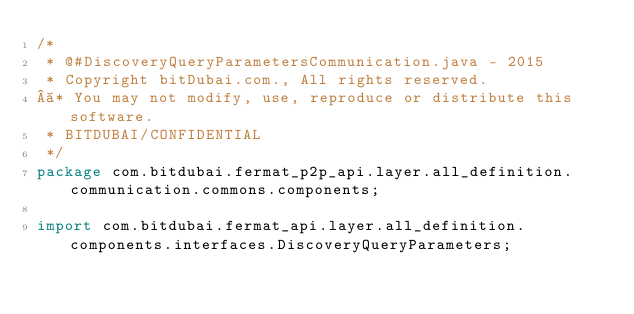<code> <loc_0><loc_0><loc_500><loc_500><_Java_>/*
 * @#DiscoveryQueryParametersCommunication.java - 2015
 * Copyright bitDubai.com., All rights reserved.
 * You may not modify, use, reproduce or distribute this software.
 * BITDUBAI/CONFIDENTIAL
 */
package com.bitdubai.fermat_p2p_api.layer.all_definition.communication.commons.components;

import com.bitdubai.fermat_api.layer.all_definition.components.interfaces.DiscoveryQueryParameters;</code> 